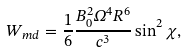Convert formula to latex. <formula><loc_0><loc_0><loc_500><loc_500>W _ { m d } = \frac { 1 } { 6 } \frac { B _ { 0 } ^ { 2 } \Omega ^ { 4 } R ^ { 6 } } { c ^ { 3 } } \sin ^ { 2 } { \chi } ,</formula> 